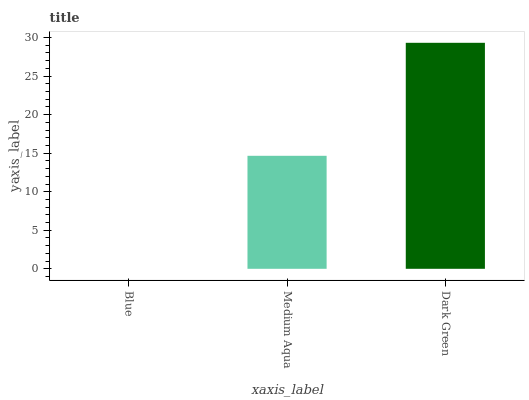Is Blue the minimum?
Answer yes or no. Yes. Is Dark Green the maximum?
Answer yes or no. Yes. Is Medium Aqua the minimum?
Answer yes or no. No. Is Medium Aqua the maximum?
Answer yes or no. No. Is Medium Aqua greater than Blue?
Answer yes or no. Yes. Is Blue less than Medium Aqua?
Answer yes or no. Yes. Is Blue greater than Medium Aqua?
Answer yes or no. No. Is Medium Aqua less than Blue?
Answer yes or no. No. Is Medium Aqua the high median?
Answer yes or no. Yes. Is Medium Aqua the low median?
Answer yes or no. Yes. Is Dark Green the high median?
Answer yes or no. No. Is Blue the low median?
Answer yes or no. No. 